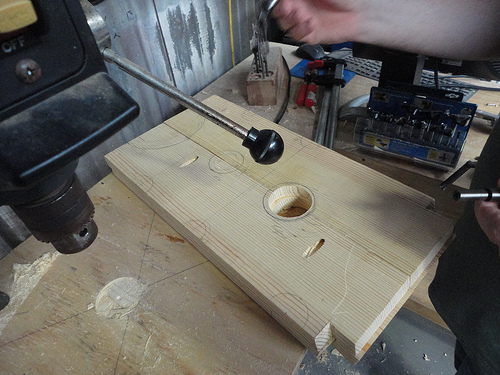<image>
Can you confirm if the machine is above the wood? Yes. The machine is positioned above the wood in the vertical space, higher up in the scene. 